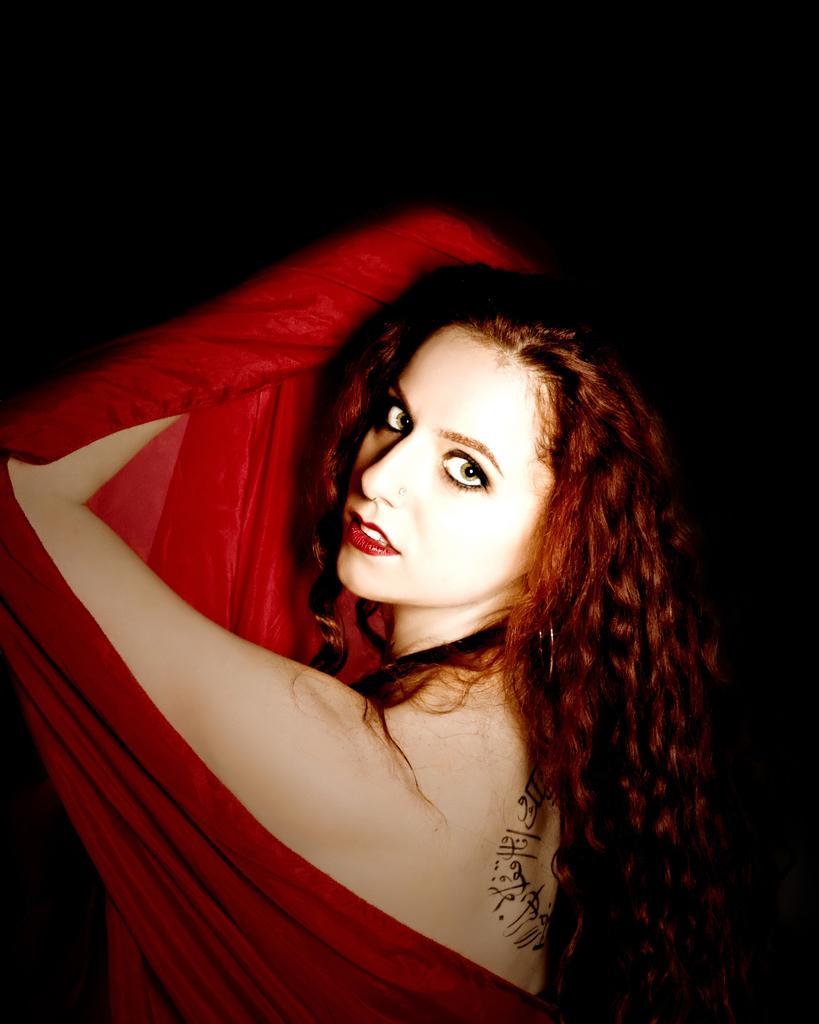How would you summarize this image in a sentence or two? In the image we can see a woman wearing clothes, nose stud and the background is dark. 